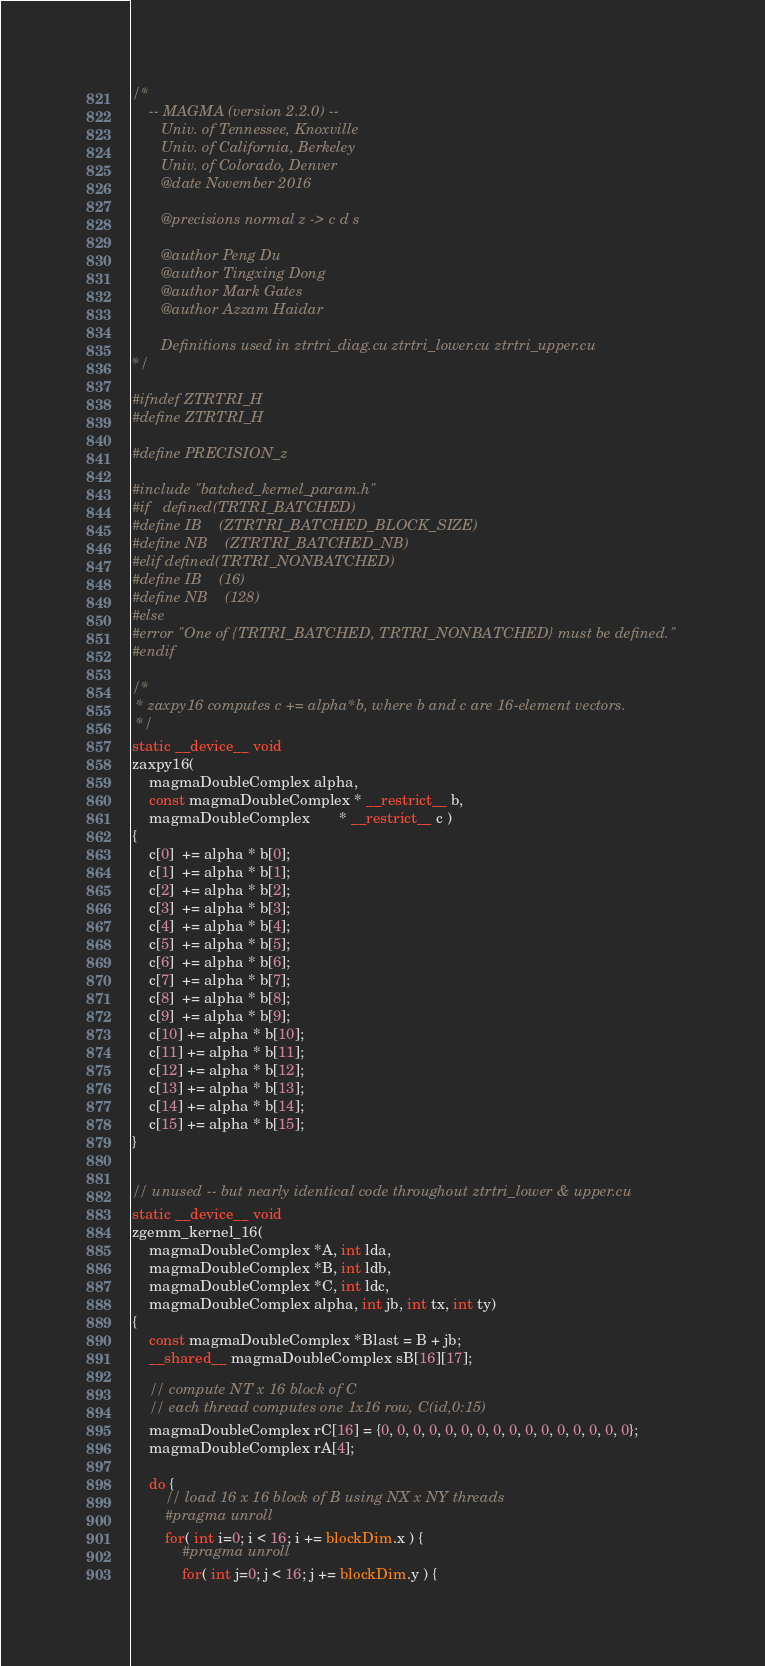Convert code to text. <code><loc_0><loc_0><loc_500><loc_500><_Cuda_>/*
    -- MAGMA (version 2.2.0) --
       Univ. of Tennessee, Knoxville
       Univ. of California, Berkeley
       Univ. of Colorado, Denver
       @date November 2016

       @precisions normal z -> c d s

       @author Peng Du
       @author Tingxing Dong
       @author Mark Gates
       @author Azzam Haidar
       
       Definitions used in ztrtri_diag.cu ztrtri_lower.cu ztrtri_upper.cu
*/

#ifndef ZTRTRI_H
#define ZTRTRI_H

#define PRECISION_z 

#include "batched_kernel_param.h"
#if   defined(TRTRI_BATCHED)
#define IB    (ZTRTRI_BATCHED_BLOCK_SIZE)
#define NB    (ZTRTRI_BATCHED_NB)
#elif defined(TRTRI_NONBATCHED)
#define IB    (16)
#define NB    (128)
#else
#error "One of {TRTRI_BATCHED, TRTRI_NONBATCHED} must be defined."
#endif

/*
 * zaxpy16 computes c += alpha*b, where b and c are 16-element vectors.
 */
static __device__ void
zaxpy16(
    magmaDoubleComplex alpha,
    const magmaDoubleComplex * __restrict__ b,
    magmaDoubleComplex       * __restrict__ c )
{
    c[0]  += alpha * b[0];
    c[1]  += alpha * b[1];
    c[2]  += alpha * b[2];
    c[3]  += alpha * b[3];
    c[4]  += alpha * b[4];
    c[5]  += alpha * b[5];
    c[6]  += alpha * b[6];
    c[7]  += alpha * b[7];
    c[8]  += alpha * b[8];
    c[9]  += alpha * b[9];
    c[10] += alpha * b[10];
    c[11] += alpha * b[11];
    c[12] += alpha * b[12];
    c[13] += alpha * b[13];
    c[14] += alpha * b[14];
    c[15] += alpha * b[15];
}


// unused -- but nearly identical code throughout ztrtri_lower & upper.cu
static __device__ void
zgemm_kernel_16(
    magmaDoubleComplex *A, int lda,
    magmaDoubleComplex *B, int ldb,
    magmaDoubleComplex *C, int ldc,
    magmaDoubleComplex alpha, int jb, int tx, int ty)
{
    const magmaDoubleComplex *Blast = B + jb;
    __shared__ magmaDoubleComplex sB[16][17];
    
    // compute NT x 16 block of C
    // each thread computes one 1x16 row, C(id,0:15)
    magmaDoubleComplex rC[16] = {0, 0, 0, 0, 0, 0, 0, 0, 0, 0, 0, 0, 0, 0, 0, 0};
    magmaDoubleComplex rA[4];

    do {
        // load 16 x 16 block of B using NX x NY threads
        #pragma unroll
        for( int i=0; i < 16; i += blockDim.x ) {
            #pragma unroll
            for( int j=0; j < 16; j += blockDim.y ) {</code> 